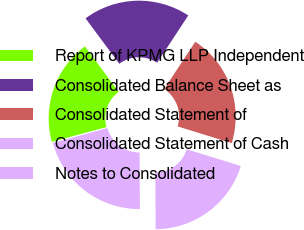<chart> <loc_0><loc_0><loc_500><loc_500><pie_chart><fcel>Report of KPMG LLP Independent<fcel>Consolidated Balance Sheet as<fcel>Consolidated Statement of<fcel>Consolidated Statement of Cash<fcel>Notes to Consolidated<nl><fcel>19.06%<fcel>19.42%<fcel>20.5%<fcel>20.14%<fcel>20.86%<nl></chart> 